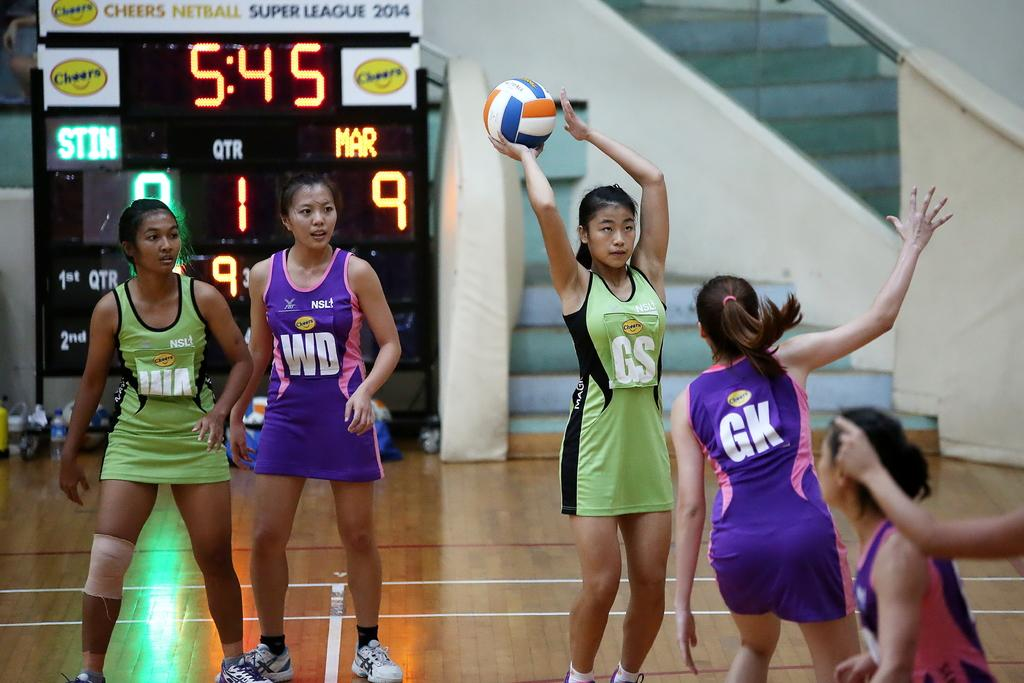What can be seen in the image? There is a group of women in the image. Where are the women located? The women are on the ground. What is one of the women holding? One woman is holding a ball. What can be seen in the background of the image? There is a scoreboard and a bottle in the background, along with other objects. Are the women wearing dresses in the image? The provided facts do not mention the type of clothing the women are wearing, so we cannot definitively answer whether they are wearing dresses or not. Is it a quiet scene in the image? The provided facts do not mention any sounds or noise levels, so we cannot definitively answer whether it is a quiet scene or not. 